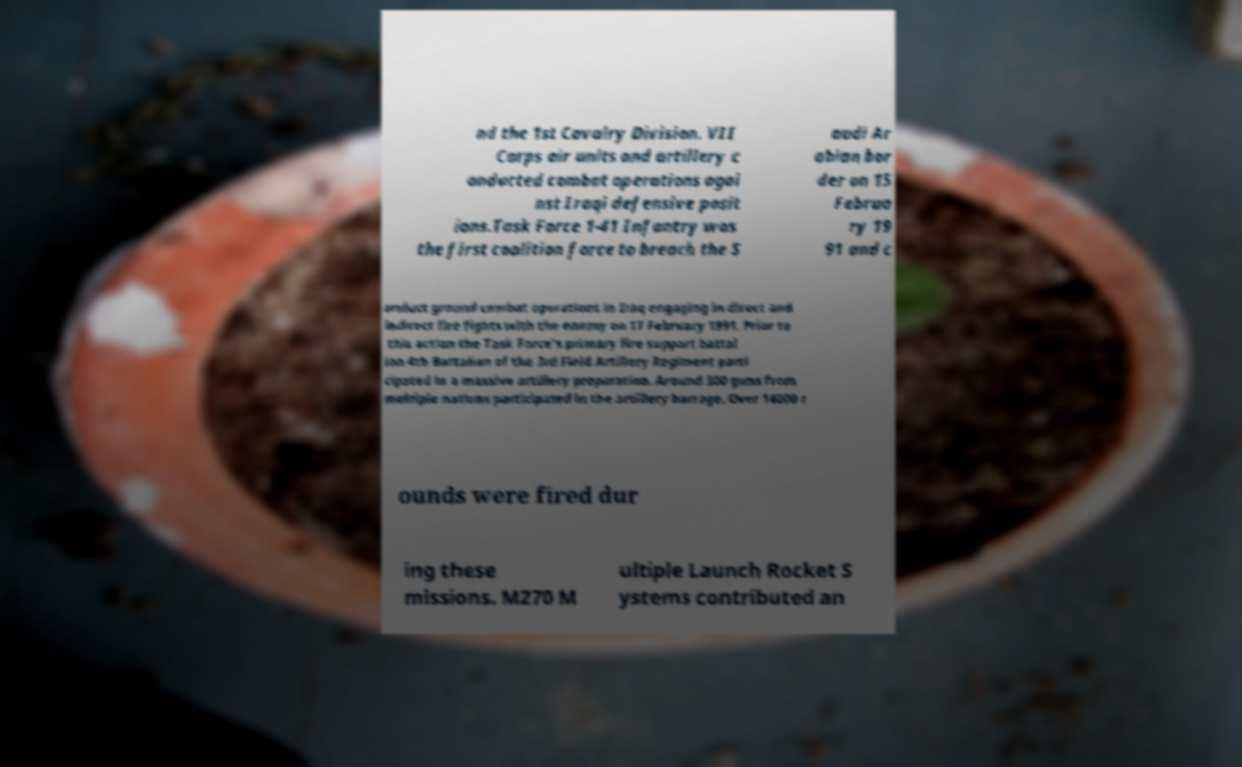Please identify and transcribe the text found in this image. nd the 1st Cavalry Division. VII Corps air units and artillery c onducted combat operations agai nst Iraqi defensive posit ions.Task Force 1-41 Infantry was the first coalition force to breach the S audi Ar abian bor der on 15 Februa ry 19 91 and c onduct ground combat operations in Iraq engaging in direct and indirect fire fights with the enemy on 17 February 1991. Prior to this action the Task Force's primary fire support battal ion 4th Battalion of the 3rd Field Artillery Regiment parti cipated in a massive artillery preparation. Around 300 guns from multiple nations participated in the artillery barrage. Over 14000 r ounds were fired dur ing these missions. M270 M ultiple Launch Rocket S ystems contributed an 